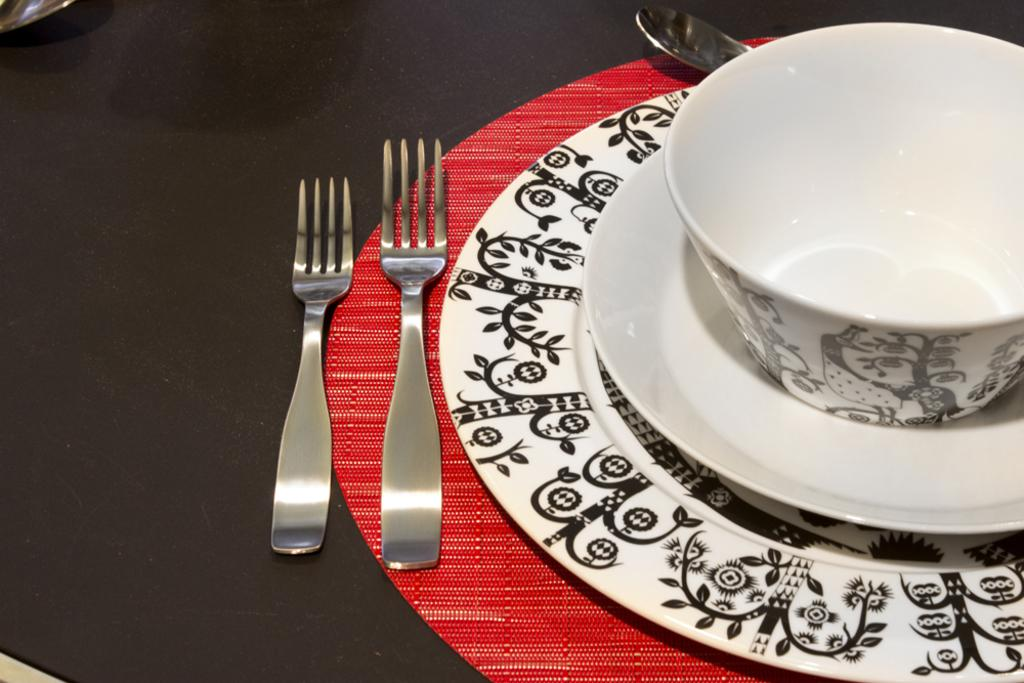What is present in the image that can hold food? There is a bowl and two plates in the image. What utensils can be seen in the image? There is a fork on a red mat, a spoon on a black surface, and another fork on the black surface. Can you describe the surfaces where the utensils are placed? The fork is on a red mat, and the spoon and another fork are on a black surface. How many eyes can be seen on the person in the image? There is no person present in the image, so it is not possible to determine the number of eyes. 